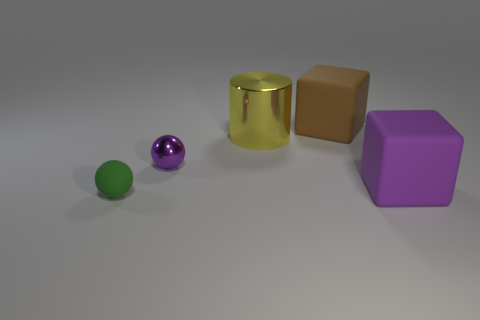Are the cube that is on the right side of the large brown block and the large thing to the left of the large brown matte cube made of the same material?
Your answer should be very brief. No. There is a big matte object in front of the metal sphere; is there a large cube that is in front of it?
Your answer should be very brief. No. The tiny sphere that is the same material as the yellow cylinder is what color?
Provide a short and direct response. Purple. Are there more large yellow metal cylinders than metallic objects?
Give a very brief answer. No. How many things are rubber objects that are left of the large purple matte block or yellow objects?
Offer a very short reply. 3. Is there a purple block that has the same size as the yellow object?
Provide a short and direct response. Yes. Are there fewer yellow objects than large cyan shiny cylinders?
Give a very brief answer. No. How many cylinders are big purple rubber objects or rubber objects?
Provide a succinct answer. 0. How many things are the same color as the rubber sphere?
Make the answer very short. 0. What is the size of the object that is both in front of the cylinder and right of the cylinder?
Ensure brevity in your answer.  Large. 